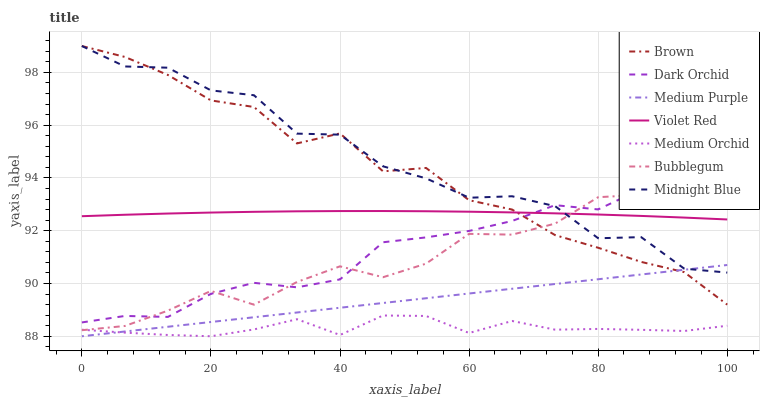Does Medium Orchid have the minimum area under the curve?
Answer yes or no. Yes. Does Midnight Blue have the maximum area under the curve?
Answer yes or no. Yes. Does Violet Red have the minimum area under the curve?
Answer yes or no. No. Does Violet Red have the maximum area under the curve?
Answer yes or no. No. Is Medium Purple the smoothest?
Answer yes or no. Yes. Is Midnight Blue the roughest?
Answer yes or no. Yes. Is Violet Red the smoothest?
Answer yes or no. No. Is Violet Red the roughest?
Answer yes or no. No. Does Medium Orchid have the lowest value?
Answer yes or no. Yes. Does Midnight Blue have the lowest value?
Answer yes or no. No. Does Midnight Blue have the highest value?
Answer yes or no. Yes. Does Violet Red have the highest value?
Answer yes or no. No. Is Medium Orchid less than Midnight Blue?
Answer yes or no. Yes. Is Violet Red greater than Medium Purple?
Answer yes or no. Yes. Does Medium Purple intersect Brown?
Answer yes or no. Yes. Is Medium Purple less than Brown?
Answer yes or no. No. Is Medium Purple greater than Brown?
Answer yes or no. No. Does Medium Orchid intersect Midnight Blue?
Answer yes or no. No. 